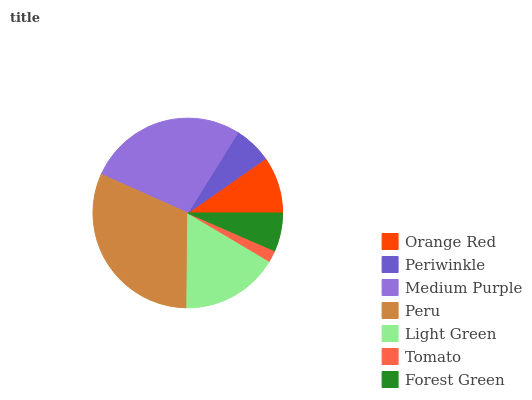Is Tomato the minimum?
Answer yes or no. Yes. Is Peru the maximum?
Answer yes or no. Yes. Is Periwinkle the minimum?
Answer yes or no. No. Is Periwinkle the maximum?
Answer yes or no. No. Is Orange Red greater than Periwinkle?
Answer yes or no. Yes. Is Periwinkle less than Orange Red?
Answer yes or no. Yes. Is Periwinkle greater than Orange Red?
Answer yes or no. No. Is Orange Red less than Periwinkle?
Answer yes or no. No. Is Orange Red the high median?
Answer yes or no. Yes. Is Orange Red the low median?
Answer yes or no. Yes. Is Light Green the high median?
Answer yes or no. No. Is Periwinkle the low median?
Answer yes or no. No. 